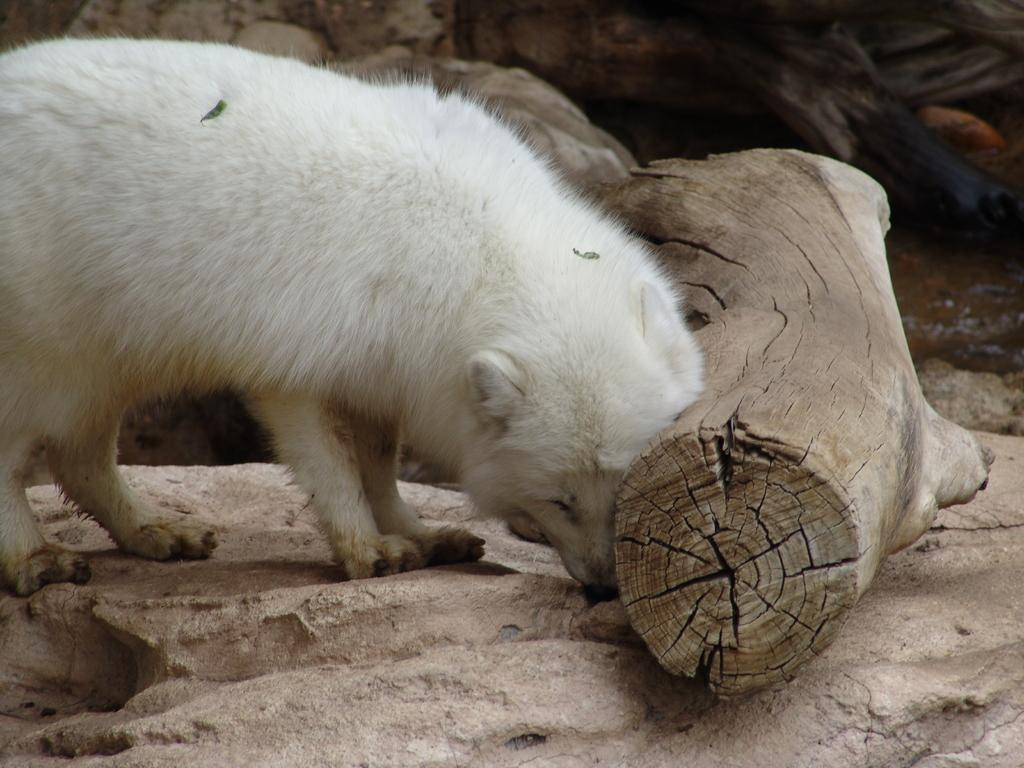What type of animal can be seen in the image? There is an animal in the image, but its specific type is not mentioned in the facts. What is the animal standing on? The animal is standing on a rock. What is the color of the animal? The animal is white in color. What is in the background of the image? There is a rock visible in the background of the image. What type of bean is growing on the tree branch in the image? There is no bean or tree branch visible in the image; the animal is standing in front of a tree branch, but no beans are mentioned. 